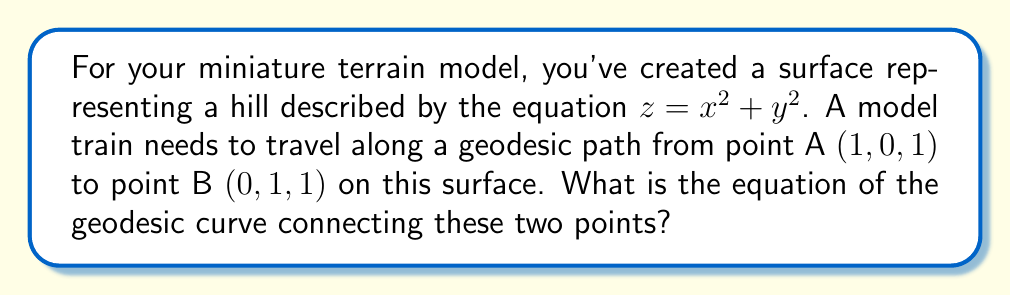Give your solution to this math problem. To find the geodesic curve on this surface, we'll follow these steps:

1) First, we need to parametrize the surface. Let's use:
   $$\mathbf{r}(u,v) = (u, v, u^2 + v^2)$$

2) The metric tensor for this surface is:
   $$g_{ij} = \begin{pmatrix}
   1+4u^2 & 4uv \\
   4uv & 1+4v^2
   \end{pmatrix}$$

3) The geodesic equations are:
   $$\frac{d^2u}{dt^2} + \Gamma^u_{uu}\left(\frac{du}{dt}\right)^2 + 2\Gamma^u_{uv}\frac{du}{dt}\frac{dv}{dt} + \Gamma^u_{vv}\left(\frac{dv}{dt}\right)^2 = 0$$
   $$\frac{d^2v}{dt^2} + \Gamma^v_{uu}\left(\frac{du}{dt}\right)^2 + 2\Gamma^v_{uv}\frac{du}{dt}\frac{dv}{dt} + \Gamma^v_{vv}\left(\frac{dv}{dt}\right)^2 = 0$$

4) Calculating the Christoffel symbols:
   $$\Gamma^u_{uu} = \frac{2u}{1+4u^2}, \Gamma^u_{uv} = \Gamma^u_{vu} = -\frac{2v}{1+4u^2}, \Gamma^u_{vv} = 0$$
   $$\Gamma^v_{uu} = 0, \Gamma^v_{uv} = \Gamma^v_{vu} = -\frac{2u}{1+4v^2}, \Gamma^v_{vv} = \frac{2v}{1+4v^2}$$

5) Substituting these into the geodesic equations gives us a system of differential equations. However, due to the symmetry of the surface and the positions of points A and B, we can deduce that the geodesic will be a straight line in the $xy$-plane.

6) The equation of the straight line connecting $(1,0)$ to $(0,1)$ in the $xy$-plane is:
   $$y = 1 - x$$

7) Therefore, the geodesic curve on the surface will be:
   $$x = t$$
   $$y = 1 - t$$
   $$z = x^2 + y^2 = t^2 + (1-t)^2 = 2t^2 - 2t + 1$$
   where $0 \leq t \leq 1$

This parametric form represents the equation of the geodesic curve connecting points A and B on the surface.
Answer: $(t, 1-t, 2t^2-2t+1)$, $0 \leq t \leq 1$ 